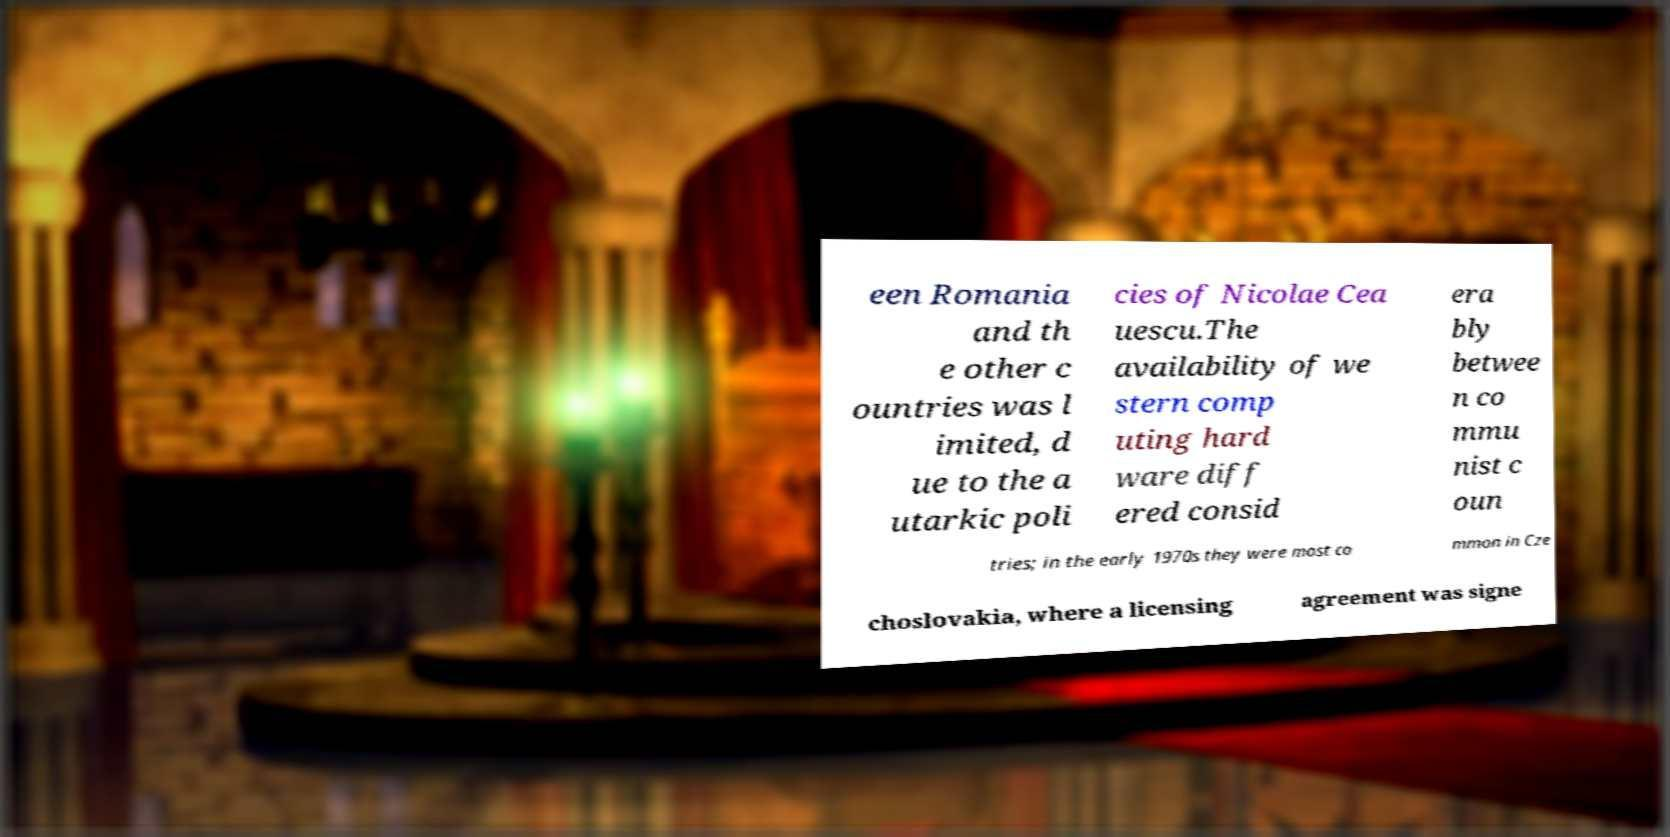What messages or text are displayed in this image? I need them in a readable, typed format. een Romania and th e other c ountries was l imited, d ue to the a utarkic poli cies of Nicolae Cea uescu.The availability of we stern comp uting hard ware diff ered consid era bly betwee n co mmu nist c oun tries; in the early 1970s they were most co mmon in Cze choslovakia, where a licensing agreement was signe 